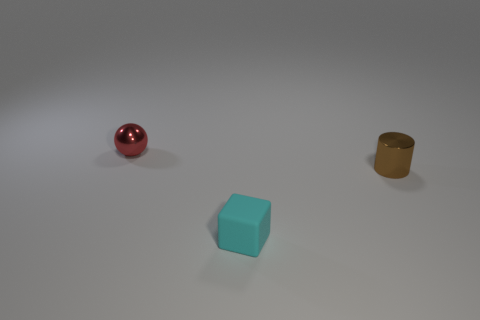Add 2 tiny cyan things. How many objects exist? 5 Subtract all cylinders. How many objects are left? 2 Subtract all metallic things. Subtract all tiny cylinders. How many objects are left? 0 Add 3 tiny red metal things. How many tiny red metal things are left? 4 Add 2 big green matte blocks. How many big green matte blocks exist? 2 Subtract 1 brown cylinders. How many objects are left? 2 